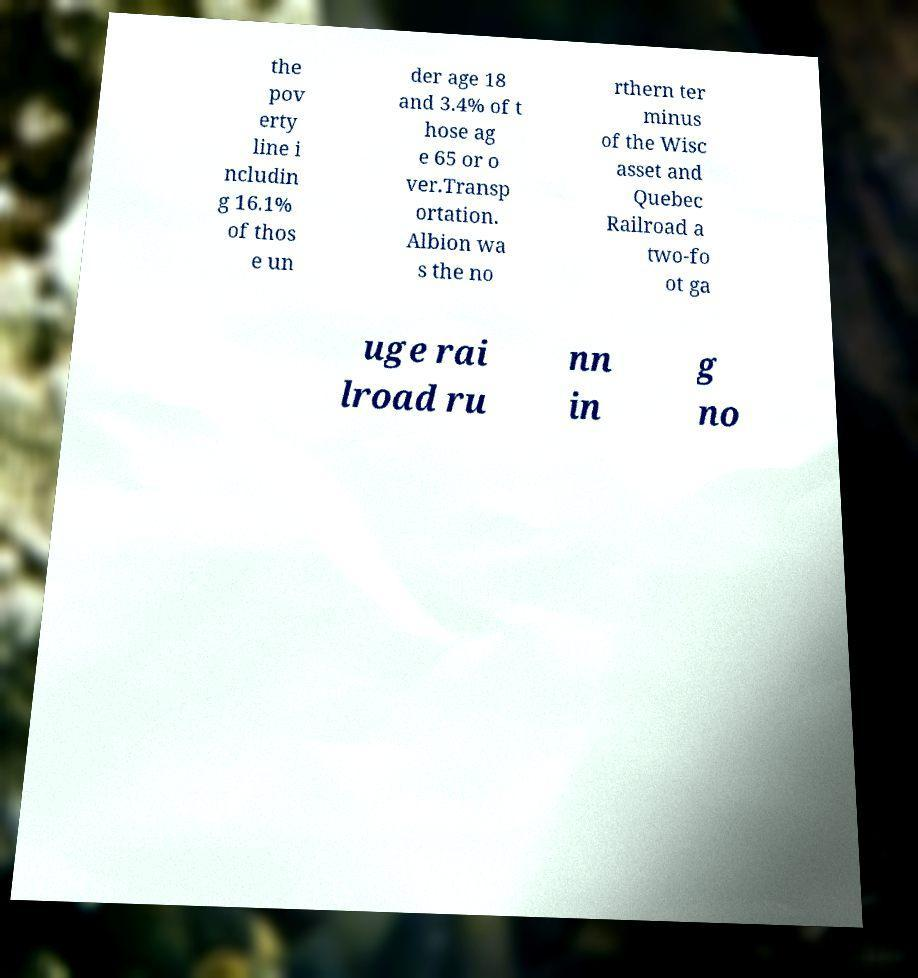Could you extract and type out the text from this image? the pov erty line i ncludin g 16.1% of thos e un der age 18 and 3.4% of t hose ag e 65 or o ver.Transp ortation. Albion wa s the no rthern ter minus of the Wisc asset and Quebec Railroad a two-fo ot ga uge rai lroad ru nn in g no 